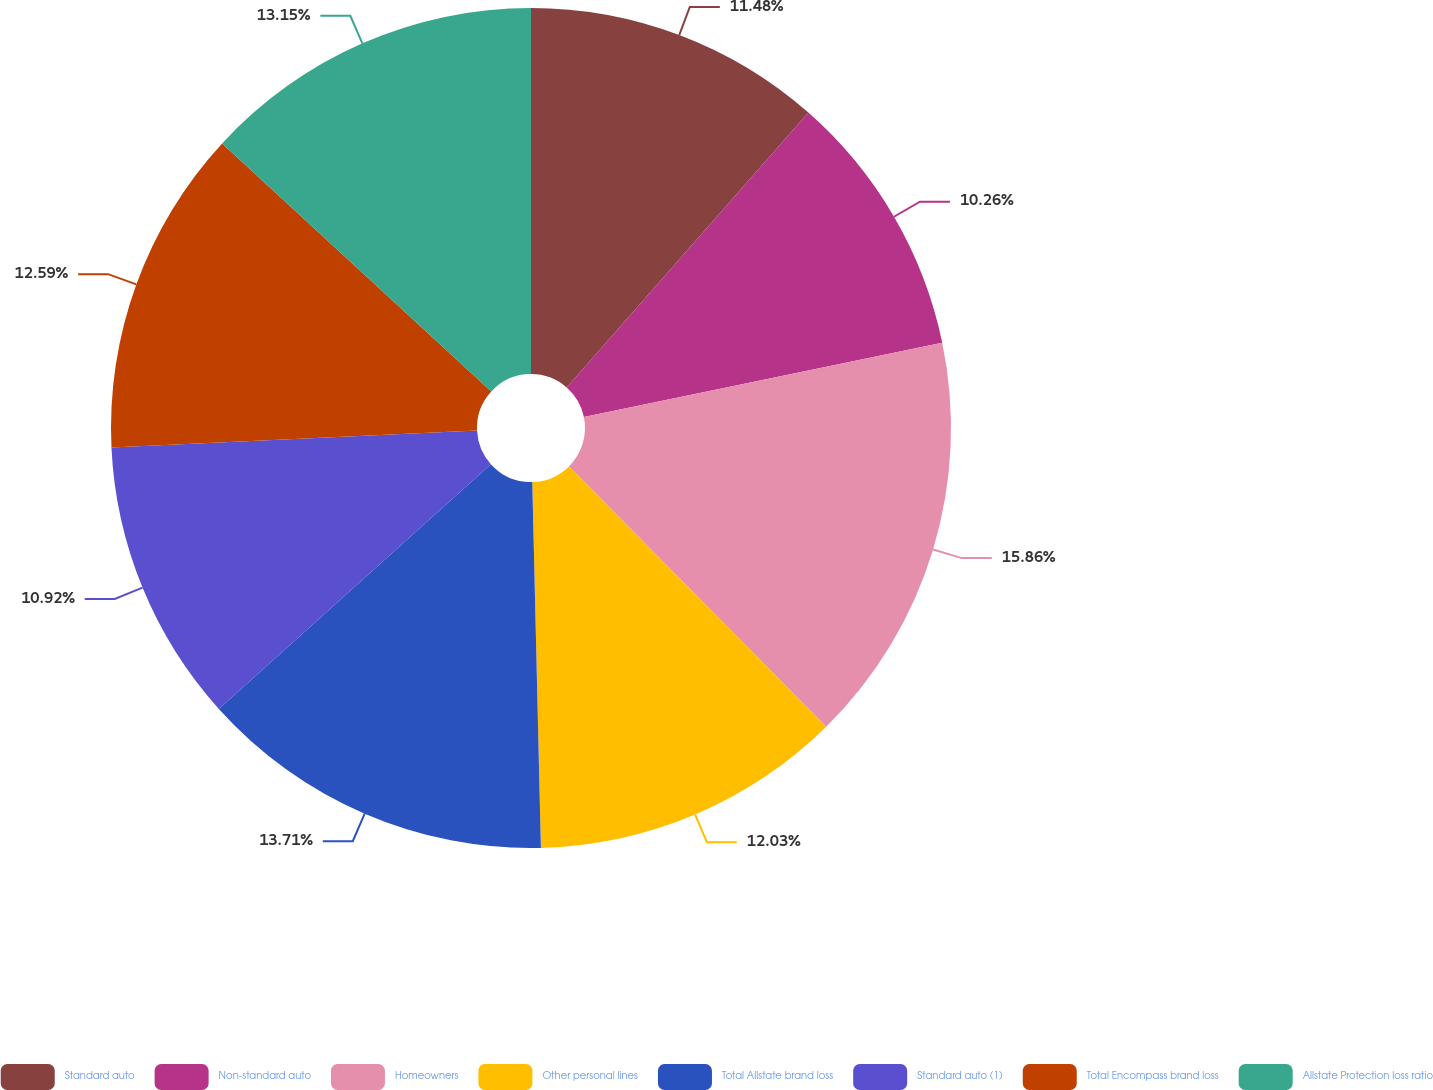<chart> <loc_0><loc_0><loc_500><loc_500><pie_chart><fcel>Standard auto<fcel>Non-standard auto<fcel>Homeowners<fcel>Other personal lines<fcel>Total Allstate brand loss<fcel>Standard auto (1)<fcel>Total Encompass brand loss<fcel>Allstate Protection loss ratio<nl><fcel>11.48%<fcel>10.26%<fcel>15.85%<fcel>12.03%<fcel>13.71%<fcel>10.92%<fcel>12.59%<fcel>13.15%<nl></chart> 